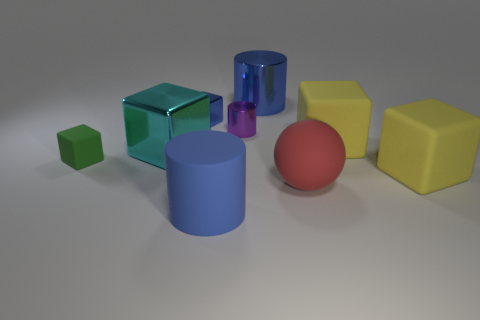What is the shape of the tiny green matte thing?
Your response must be concise. Cube. What is the size of the metal object that is the same color as the tiny metallic cube?
Your response must be concise. Large. There is a blue cylinder that is behind the tiny block that is behind the cyan shiny block; what is its size?
Offer a terse response. Large. There is a cylinder behind the blue cube; how big is it?
Your response must be concise. Large. Are there fewer big metallic objects that are behind the small blue object than blue shiny things that are in front of the cyan block?
Make the answer very short. No. What color is the large shiny cylinder?
Ensure brevity in your answer.  Blue. Are there any metal cubes that have the same color as the big metal cylinder?
Give a very brief answer. Yes. The big blue thing that is on the left side of the purple shiny object that is right of the small shiny thing behind the small purple metal object is what shape?
Ensure brevity in your answer.  Cylinder. What is the large blue cylinder in front of the tiny shiny block made of?
Provide a succinct answer. Rubber. There is a blue object that is in front of the big metallic object in front of the big blue object behind the large cyan thing; how big is it?
Your answer should be compact. Large. 